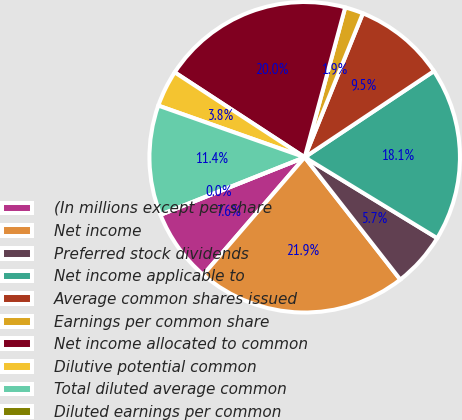Convert chart. <chart><loc_0><loc_0><loc_500><loc_500><pie_chart><fcel>(In millions except per share<fcel>Net income<fcel>Preferred stock dividends<fcel>Net income applicable to<fcel>Average common shares issued<fcel>Earnings per common share<fcel>Net income allocated to common<fcel>Dilutive potential common<fcel>Total diluted average common<fcel>Diluted earnings per common<nl><fcel>7.63%<fcel>21.89%<fcel>5.72%<fcel>18.08%<fcel>9.53%<fcel>1.91%<fcel>19.99%<fcel>3.81%<fcel>11.44%<fcel>0.0%<nl></chart> 